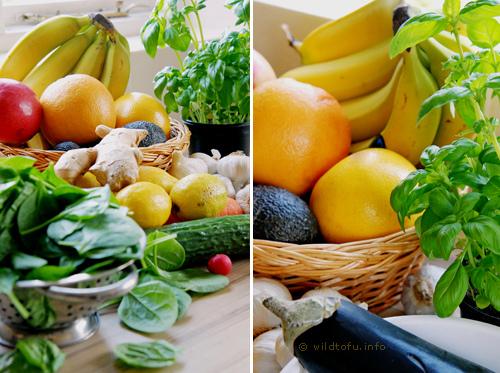What are the long, yellow fruits?
Quick response, please. Bananas. Is there any eggplant visible?
Concise answer only. Yes. What kind of dish in the spinach in?
Short answer required. Colander. 